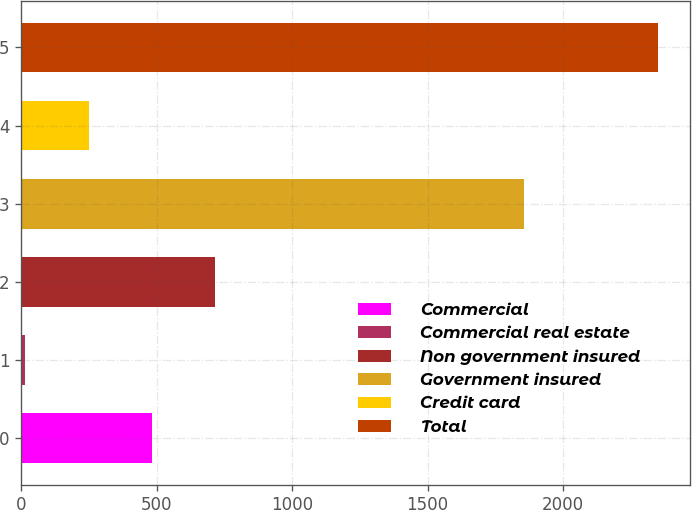<chart> <loc_0><loc_0><loc_500><loc_500><bar_chart><fcel>Commercial<fcel>Commercial real estate<fcel>Non government insured<fcel>Government insured<fcel>Credit card<fcel>Total<nl><fcel>482.2<fcel>15<fcel>715.8<fcel>1855<fcel>248.6<fcel>2351<nl></chart> 